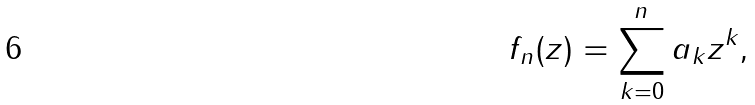<formula> <loc_0><loc_0><loc_500><loc_500>f _ { n } ( z ) = \sum _ { k = 0 } ^ { n } a _ { k } z ^ { k } ,</formula> 